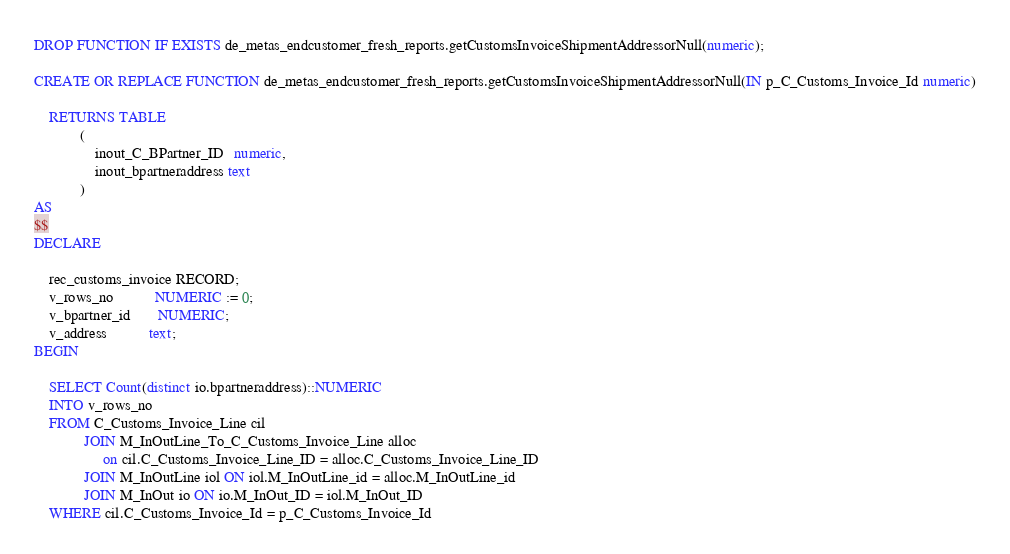<code> <loc_0><loc_0><loc_500><loc_500><_SQL_>DROP FUNCTION IF EXISTS de_metas_endcustomer_fresh_reports.getCustomsInvoiceShipmentAddressorNull(numeric);

CREATE OR REPLACE FUNCTION de_metas_endcustomer_fresh_reports.getCustomsInvoiceShipmentAddressorNull(IN p_C_Customs_Invoice_Id numeric)

    RETURNS TABLE
            (
                inout_C_BPartner_ID   numeric,
                inout_bpartneraddress text
            )
AS
$$
DECLARE

    rec_customs_invoice RECORD;
    v_rows_no           NUMERIC := 0;
    v_bpartner_id       NUMERIC;
    v_address           text;
BEGIN

    SELECT Count(distinct io.bpartneraddress)::NUMERIC
    INTO v_rows_no
    FROM C_Customs_Invoice_Line cil
             JOIN M_InOutLine_To_C_Customs_Invoice_Line alloc
                  on cil.C_Customs_Invoice_Line_ID = alloc.C_Customs_Invoice_Line_ID
             JOIN M_InOutLine iol ON iol.M_InOutLine_id = alloc.M_InOutLine_id
             JOIN M_InOut io ON io.M_InOut_ID = iol.M_InOut_ID
    WHERE cil.C_Customs_Invoice_Id = p_C_Customs_Invoice_Id</code> 